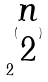Convert formula to latex. <formula><loc_0><loc_0><loc_500><loc_500>2 ^ { ( \begin{matrix} n \\ 2 \end{matrix} ) }</formula> 